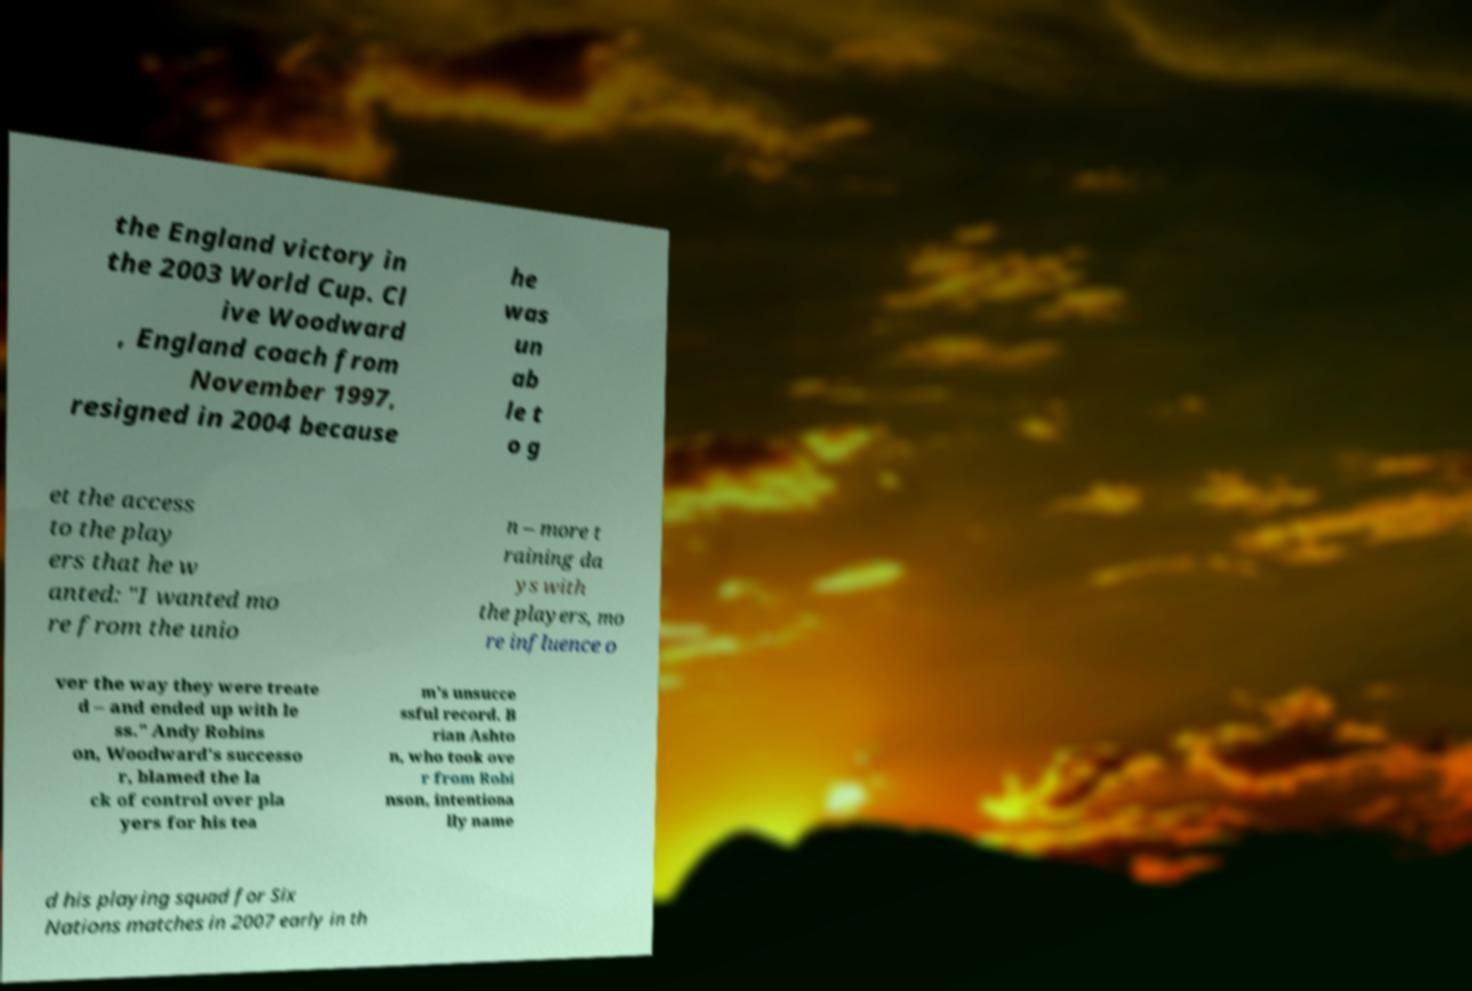I need the written content from this picture converted into text. Can you do that? the England victory in the 2003 World Cup. Cl ive Woodward , England coach from November 1997, resigned in 2004 because he was un ab le t o g et the access to the play ers that he w anted: "I wanted mo re from the unio n – more t raining da ys with the players, mo re influence o ver the way they were treate d – and ended up with le ss." Andy Robins on, Woodward's successo r, blamed the la ck of control over pla yers for his tea m's unsucce ssful record. B rian Ashto n, who took ove r from Robi nson, intentiona lly name d his playing squad for Six Nations matches in 2007 early in th 